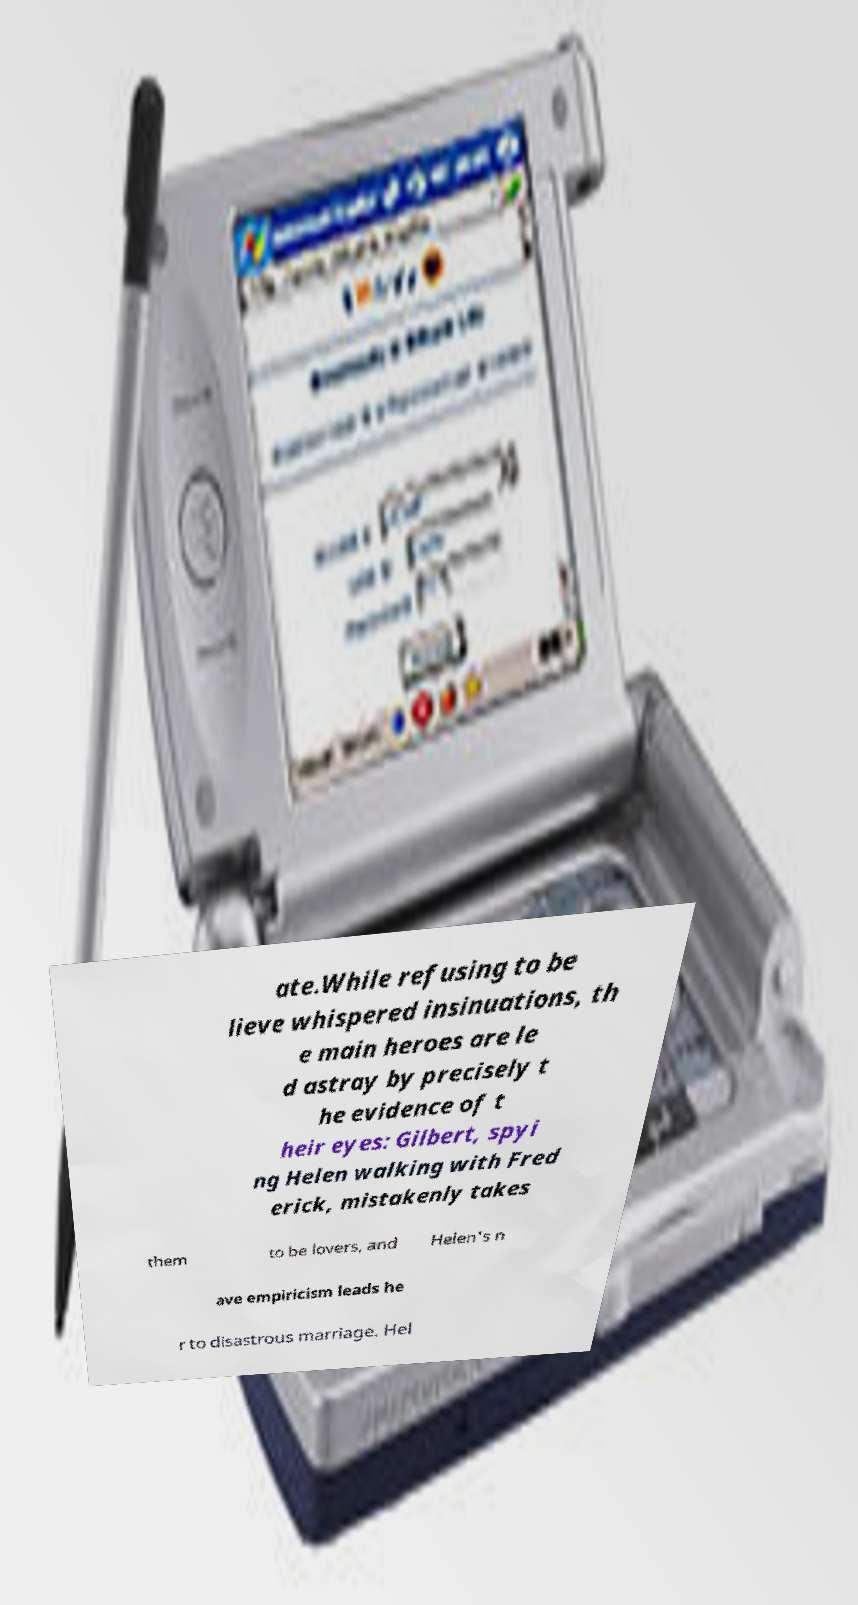For documentation purposes, I need the text within this image transcribed. Could you provide that? ate.While refusing to be lieve whispered insinuations, th e main heroes are le d astray by precisely t he evidence of t heir eyes: Gilbert, spyi ng Helen walking with Fred erick, mistakenly takes them to be lovers, and Helen's n ave empiricism leads he r to disastrous marriage. Hel 